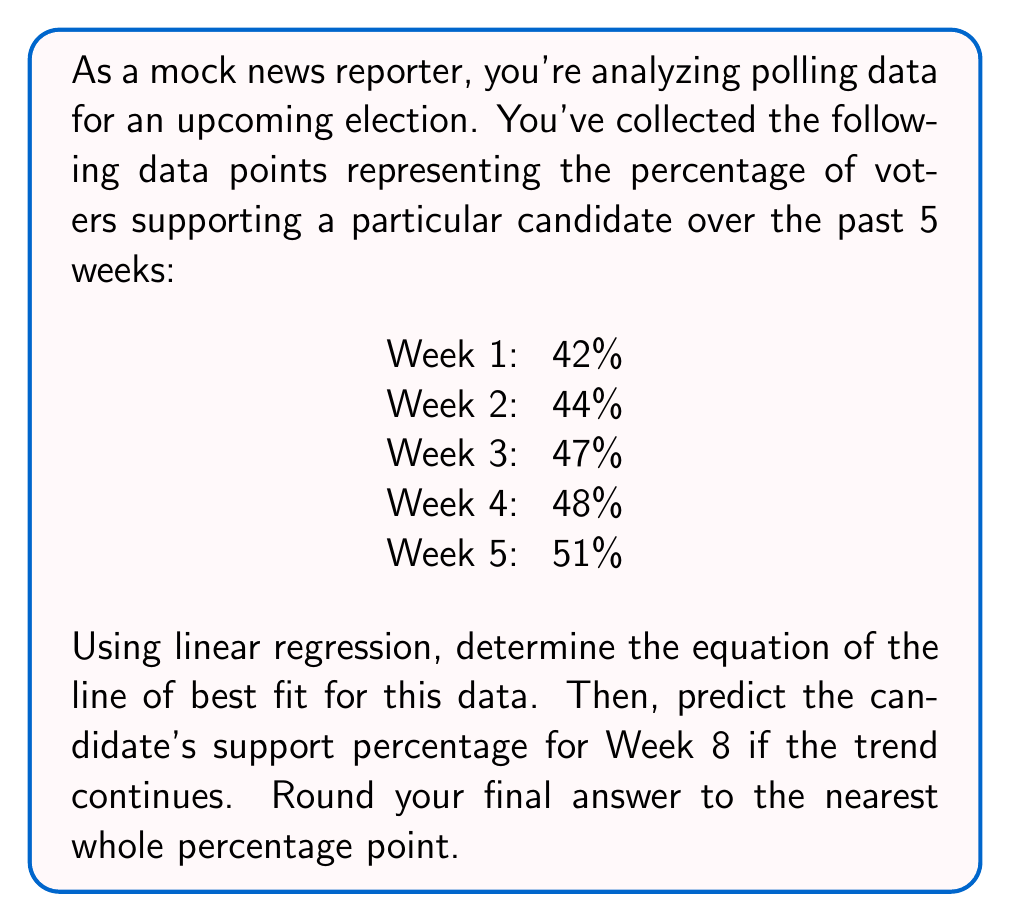Show me your answer to this math problem. To solve this problem, we'll use linear regression to find the line of best fit. Let's follow these steps:

1. Assign x-values to the weeks (1-5) and y-values to the percentages.

2. Calculate the means of x and y:
   $\bar{x} = \frac{1 + 2 + 3 + 4 + 5}{5} = 3$
   $\bar{y} = \frac{42 + 44 + 47 + 48 + 51}{5} = 46.4$

3. Calculate the slope (m) using the formula:
   $$m = \frac{\sum(x_i - \bar{x})(y_i - \bar{y})}{\sum(x_i - \bar{x})^2}$$

   Numerator: $(-2)(-4.4) + (-1)(-2.4) + (0)(0.6) + (1)(1.6) + (2)(4.6) = 20$
   Denominator: $(-2)^2 + (-1)^2 + 0^2 + 1^2 + 2^2 = 10$

   $m = \frac{20}{10} = 2$

4. Use the point-slope form to find the y-intercept (b):
   $46.4 = 2(3) + b$
   $b = 46.4 - 6 = 40.4$

5. The equation of the line of best fit is:
   $y = 2x + 40.4$

6. To predict the support percentage for Week 8, substitute x = 8:
   $y = 2(8) + 40.4 = 56.4$

7. Rounding to the nearest whole percentage point:
   56.4% ≈ 56%
Answer: The predicted support percentage for the candidate in Week 8 is 56%. 